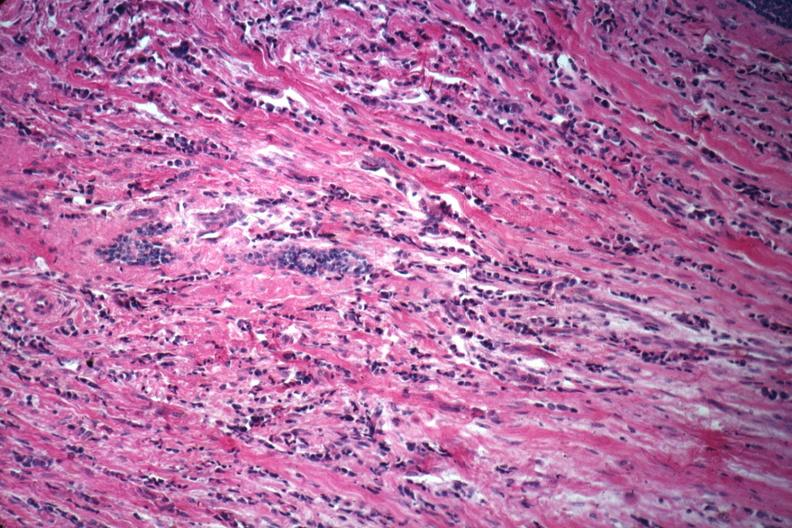s breast present?
Answer the question using a single word or phrase. Yes 